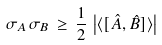<formula> <loc_0><loc_0><loc_500><loc_500>\sigma _ { A } \, \sigma _ { B } \, \geq \, { \frac { 1 } { 2 } } \, \left | \langle [ { \hat { A } } , { \hat { B } } ] \rangle \right |</formula> 